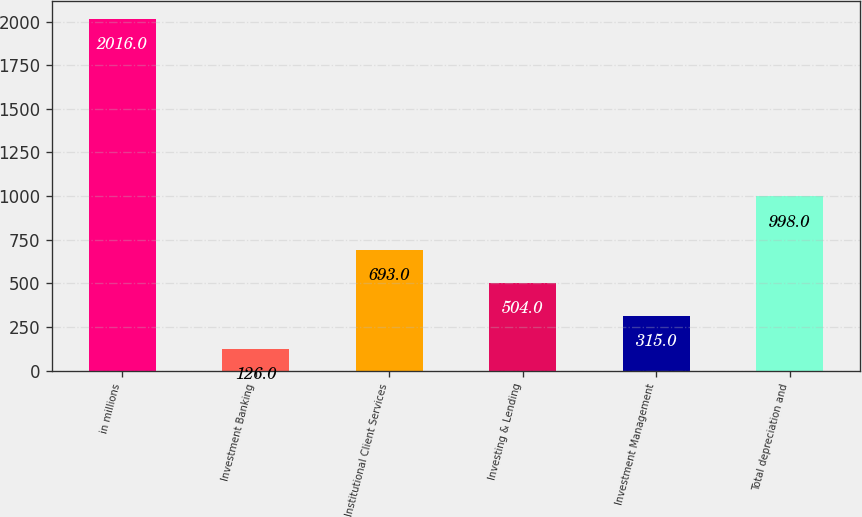Convert chart to OTSL. <chart><loc_0><loc_0><loc_500><loc_500><bar_chart><fcel>in millions<fcel>Investment Banking<fcel>Institutional Client Services<fcel>Investing & Lending<fcel>Investment Management<fcel>Total depreciation and<nl><fcel>2016<fcel>126<fcel>693<fcel>504<fcel>315<fcel>998<nl></chart> 